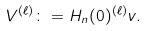<formula> <loc_0><loc_0><loc_500><loc_500>V ^ { ( \ell ) } \colon = H _ { n } ( 0 ) ^ { ( \ell ) } v .</formula> 